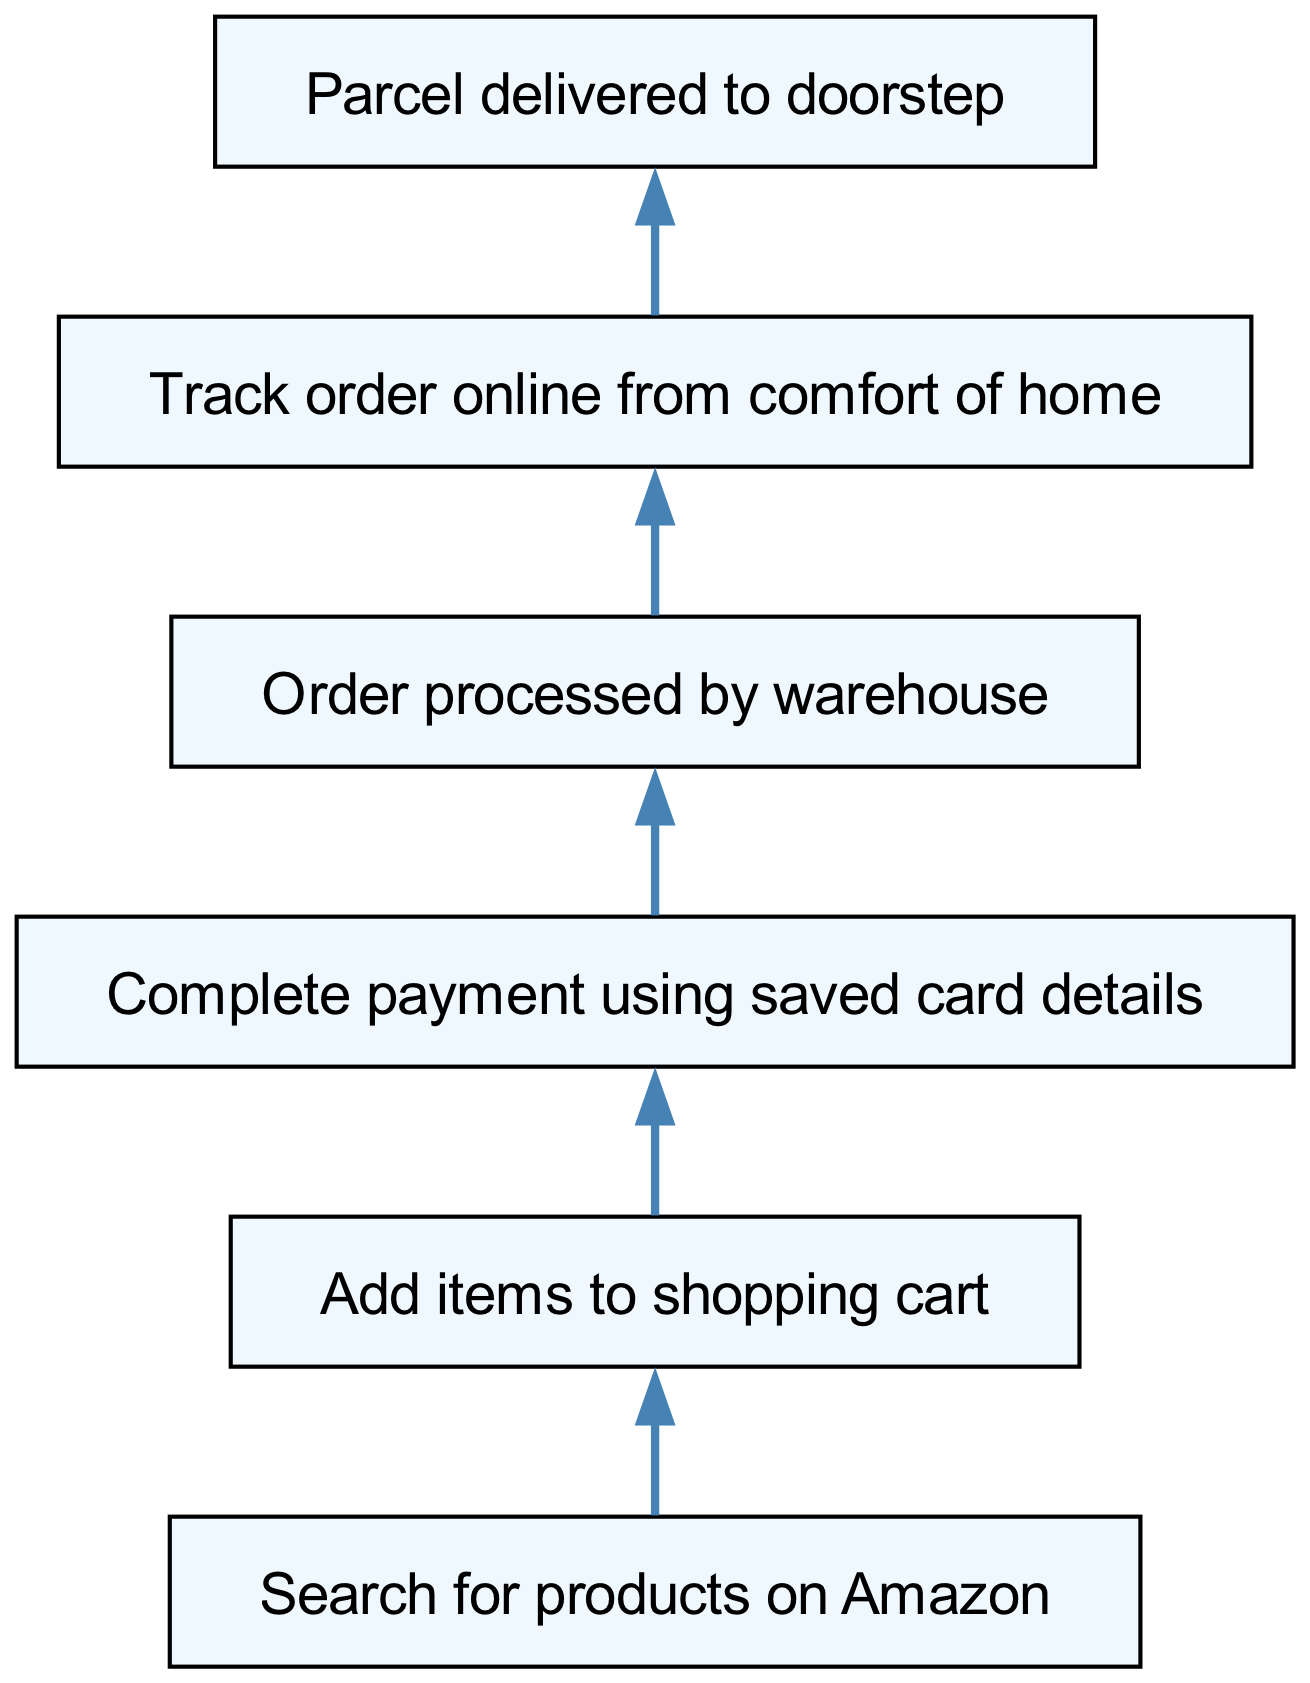What is the first step in the order lifecycle? The first step of the lifecycle is indicated by the bottom node named "Search for products on Amazon," which is where users begin their shopping journey.
Answer: Search for products on Amazon How many steps are there in the lifecycle of an online order? By counting the distinct steps in the diagram, starting from "Search for products on Amazon" to "Parcel delivered to doorstep," there are five main steps illustrated.
Answer: Five What comes after adding items to the shopping cart? The diagram shows that after "Add items to shopping cart," the next step is "Complete payment using saved card details," indicating a clear progression in the ordering process.
Answer: Complete payment using saved card details What is the connection between processing and delivery? The connection between "Order processed by warehouse" and "Parcel delivered to doorstep" represents a sequential relationship where the order must be processed before it can be delivered, showing that one directly leads to the other.
Answer: Order processed by warehouse Which action requires tracking the order? According to the diagram flow, "Track order online from comfort of home" naturally follows "Order processed by warehouse," meaning tracking happens after the order has been processed.
Answer: Order processed by warehouse What is the last step of the order lifecycle? The final step shown in the diagram is "Parcel delivered to doorstep," which signifies the end of the order processing and delivery journey for online shopping.
Answer: Parcel delivered to doorstep How many connections are there in total? By counting each arrow/connection in the diagram between the steps, there are a total of five connections illustrated, each indicating a specific transition from one step to the next.
Answer: Five What is the flow direction of the diagram? The diagram follows a bottom-up structure, meaning that the flow direction moves upward, transitioning from the initial search step to the final delivery step.
Answer: Upward What action directly precedes order processing? "Complete payment using saved card details" is the immediate action that takes place just before the order is processed by warehouse, indicating a critical step in maintaining order flow.
Answer: Complete payment using saved card details 